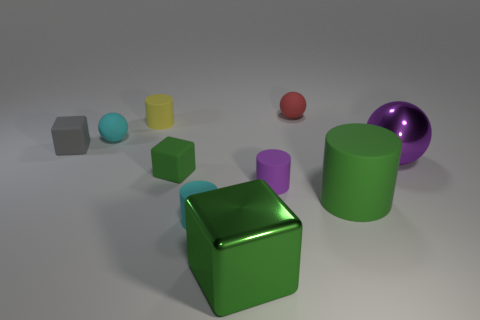Is the color of the large rubber thing the same as the tiny matte object that is in front of the big green rubber cylinder?
Your answer should be very brief. No. How many cyan objects are the same shape as the purple rubber object?
Provide a succinct answer. 1. There is a green cube that is behind the big green block; what is it made of?
Ensure brevity in your answer.  Rubber. There is a purple object that is left of the big purple object; does it have the same shape as the small red matte object?
Ensure brevity in your answer.  No. Are there any yellow matte spheres that have the same size as the purple shiny ball?
Give a very brief answer. No. Is the shape of the yellow rubber thing the same as the matte thing that is on the left side of the tiny cyan rubber sphere?
Give a very brief answer. No. There is a large rubber object that is the same color as the big metallic cube; what is its shape?
Make the answer very short. Cylinder. Are there fewer large purple spheres behind the small red rubber ball than matte objects?
Ensure brevity in your answer.  Yes. Does the small gray matte thing have the same shape as the small green thing?
Provide a short and direct response. Yes. What is the size of the green cylinder that is the same material as the tiny red object?
Provide a short and direct response. Large. 